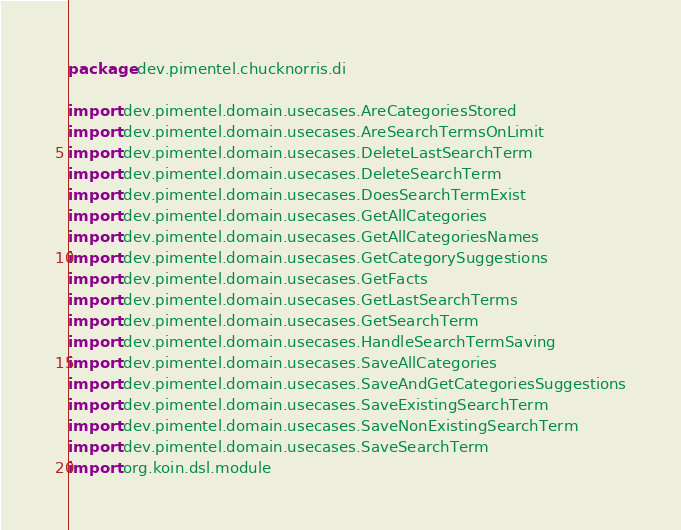Convert code to text. <code><loc_0><loc_0><loc_500><loc_500><_Kotlin_>package dev.pimentel.chucknorris.di

import dev.pimentel.domain.usecases.AreCategoriesStored
import dev.pimentel.domain.usecases.AreSearchTermsOnLimit
import dev.pimentel.domain.usecases.DeleteLastSearchTerm
import dev.pimentel.domain.usecases.DeleteSearchTerm
import dev.pimentel.domain.usecases.DoesSearchTermExist
import dev.pimentel.domain.usecases.GetAllCategories
import dev.pimentel.domain.usecases.GetAllCategoriesNames
import dev.pimentel.domain.usecases.GetCategorySuggestions
import dev.pimentel.domain.usecases.GetFacts
import dev.pimentel.domain.usecases.GetLastSearchTerms
import dev.pimentel.domain.usecases.GetSearchTerm
import dev.pimentel.domain.usecases.HandleSearchTermSaving
import dev.pimentel.domain.usecases.SaveAllCategories
import dev.pimentel.domain.usecases.SaveAndGetCategoriesSuggestions
import dev.pimentel.domain.usecases.SaveExistingSearchTerm
import dev.pimentel.domain.usecases.SaveNonExistingSearchTerm
import dev.pimentel.domain.usecases.SaveSearchTerm
import org.koin.dsl.module
</code> 